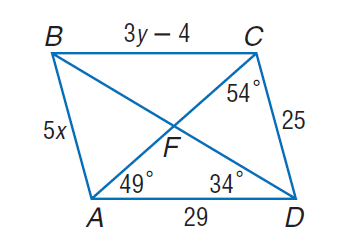Answer the mathemtical geometry problem and directly provide the correct option letter.
Question: Use parallelogram A B C D to find m \angle B C F.
Choices: A: 34 B: 49 C: 54 D: 83 B 